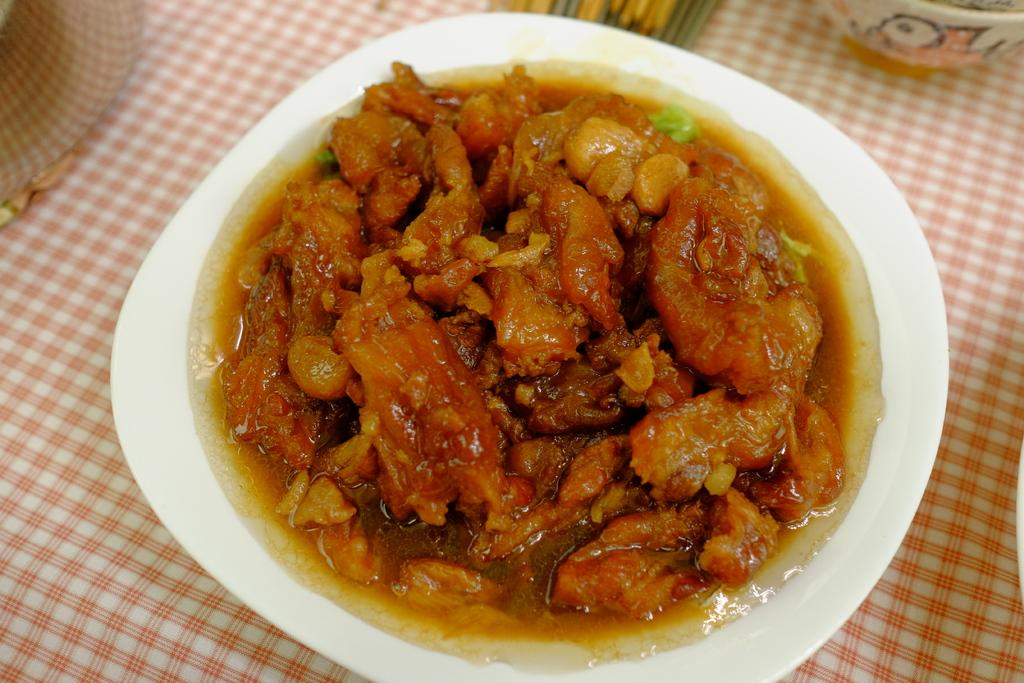What is on the plate in the image? There is a food item on a plate in the image. Where is the plate located in the image? The plate is on top of a table in the image. What type of brake is used to stop the governor in the image? There is no governor or brake present in the image; it only features a food item on a plate and a table. 